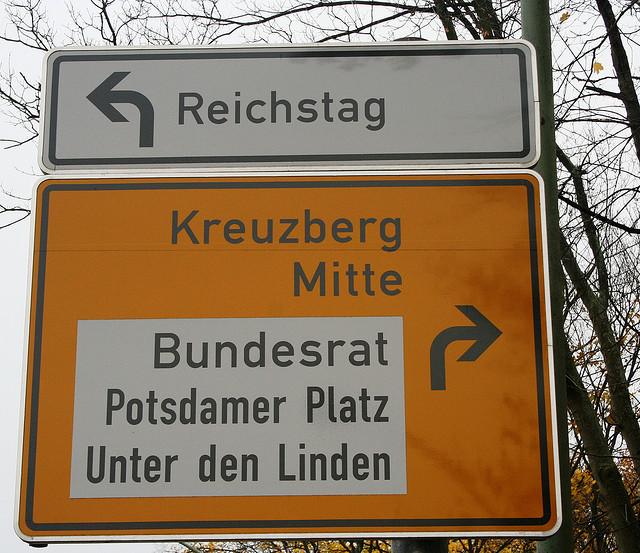Where is the arrow pointing?
Short answer required. Left and right. Is this a legal traffic sign?
Keep it brief. Yes. Where are the arrows pointing?
Answer briefly. Left and right. What color is the sign?
Keep it brief. Orange. What is behind the sign?
Concise answer only. Tree. 